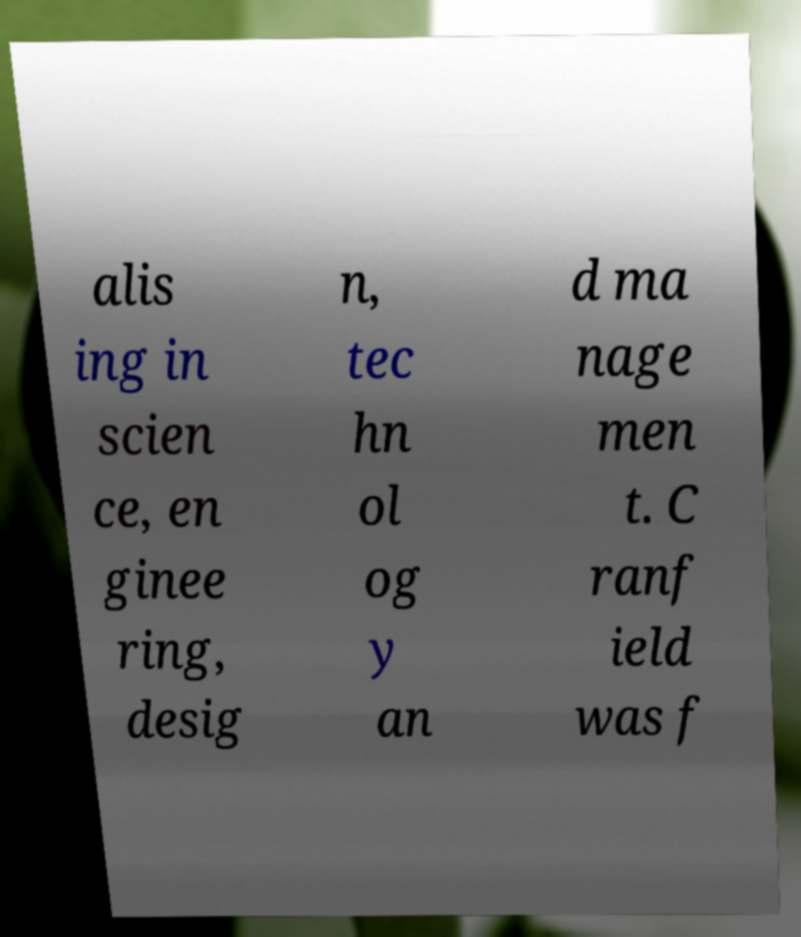For documentation purposes, I need the text within this image transcribed. Could you provide that? alis ing in scien ce, en ginee ring, desig n, tec hn ol og y an d ma nage men t. C ranf ield was f 